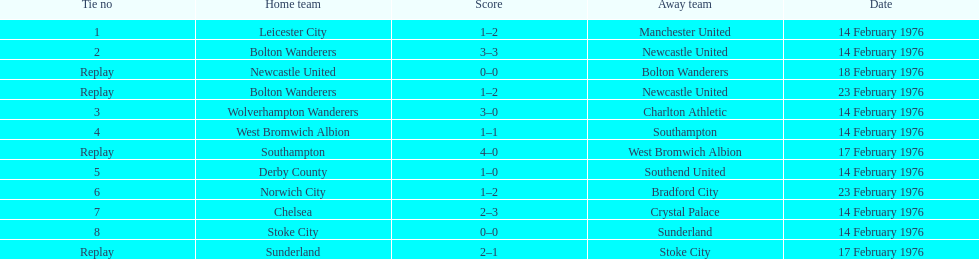How many games did the bolton wanderers and newcastle united play before there was a definitive winner in the fifth round proper? 3. 